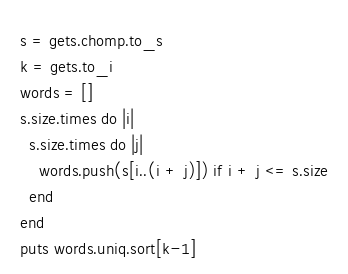Convert code to text. <code><loc_0><loc_0><loc_500><loc_500><_Ruby_>s = gets.chomp.to_s
k = gets.to_i
words = []
s.size.times do |i|
  s.size.times do |j|
    words.push(s[i..(i + j)]) if i + j <= s.size
  end
end
puts words.uniq.sort[k-1]
</code> 